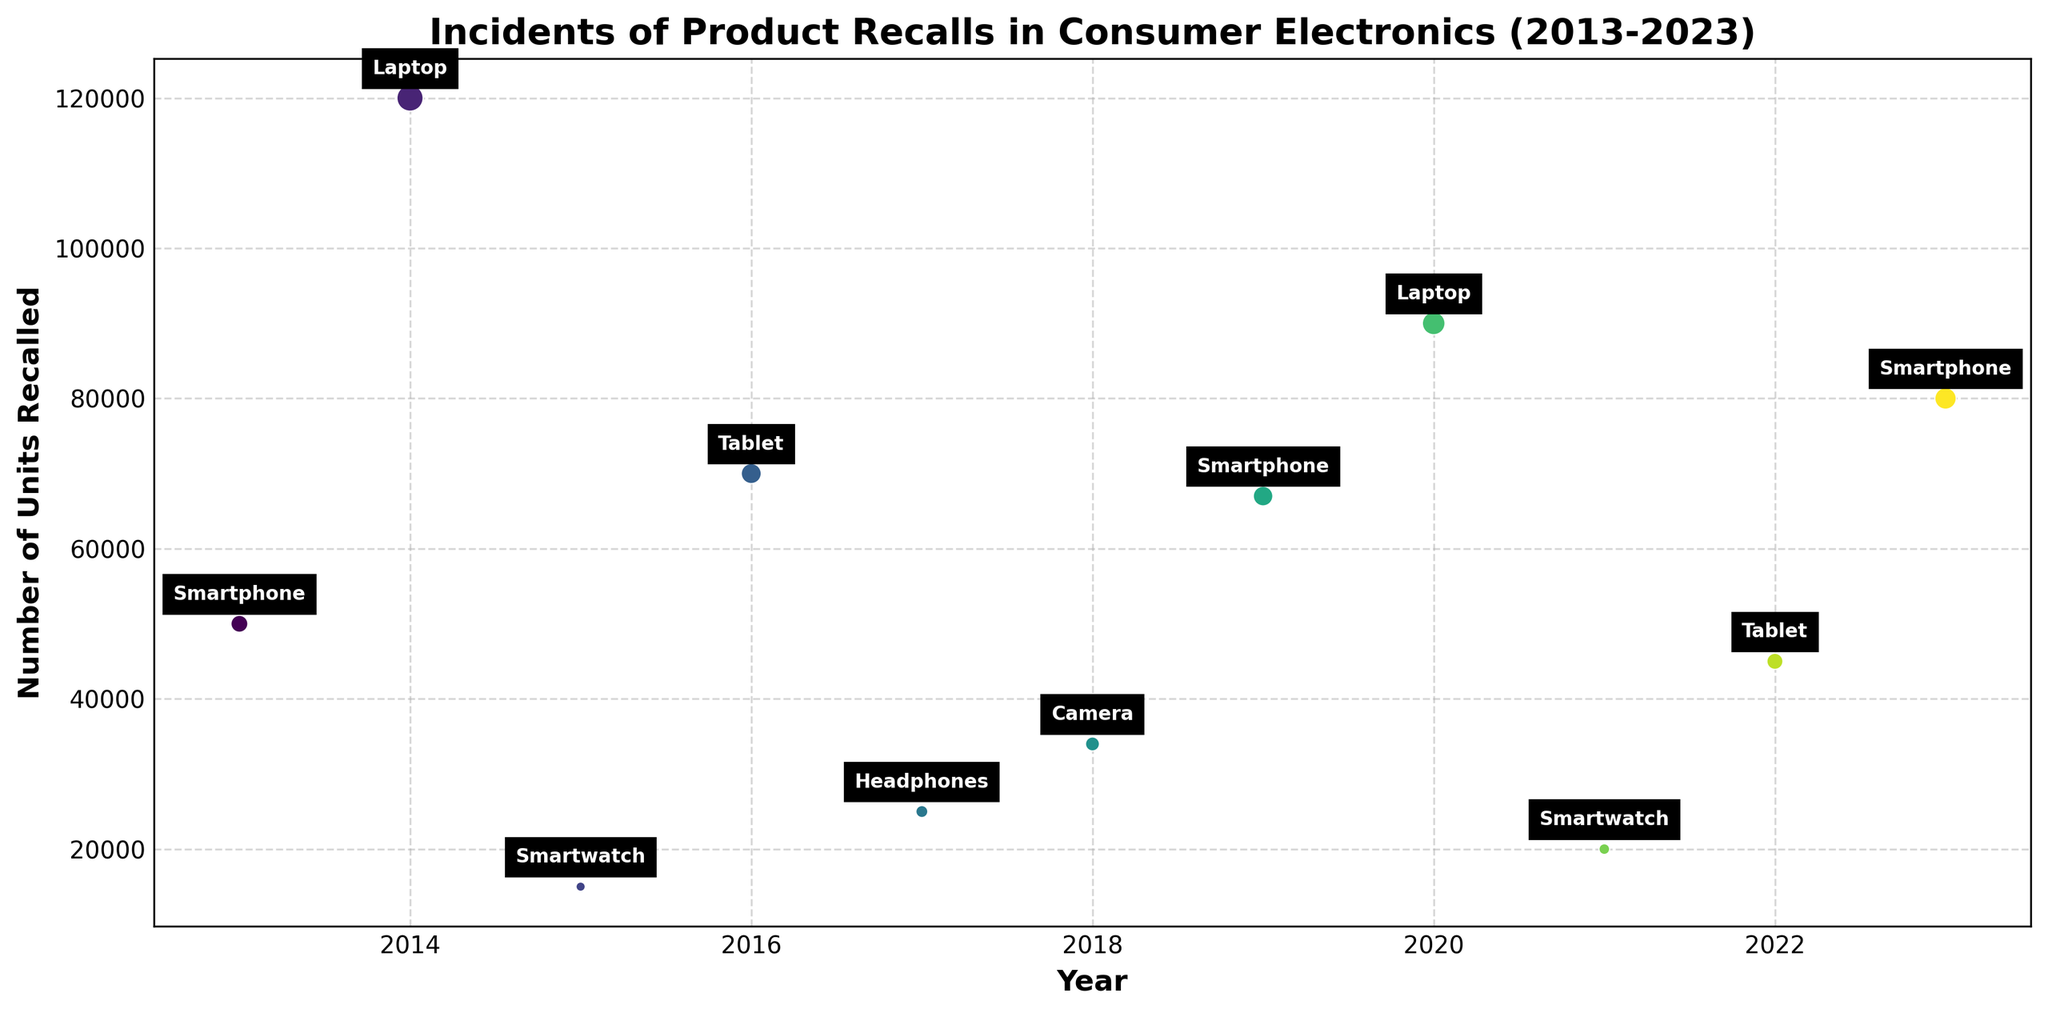What year had the highest number of product recalls? By inspecting the vertical positions on the y-axis, we can see which point is the highest. In the figure, the year 2014 has the highest point with 120,000 units recalled.
Answer: 2014 Which years had incidents of smartphone recalls, and how many units were recalled in each year? Look for the annotated labels "Smartphone" and note the corresponding years and y-axis positions. There are incidents in 2013 with 50,000 units, 2019 with 67,000 units, and 2023 with 80,000 units.
Answer: 2013 (50,000), 2019 (67,000), 2023 (80,000) What is the average number of units recalled in the years when Innovatech had incidents? Identify the points labeled "Tablet" associated with Innovatech in 2016 and 2022. Summing the units recalled (70,000 + 45,000) gives 115,000 units. Dividing this sum by the 2 incidents gives an average of 57,500 units.
Answer: 57,500 How did the number of units recalled for smartphones by ABC Electronics change from 2013 to 2019? Locate the incidents in 2013 and 2019 for ABC Electronics and compare the y-axis values. In 2013, 50,000 units were recalled, and in 2019, 67,000 units were recalled. The difference is 67,000 - 50,000 = 17,000 units.
Answer: Increased by 17,000 units Which product and year had the second-highest number of units recalled? Find the second highest point on the y-axis after the highest one in 2014. The second-highest point is in 2020 for laptops with 90,000 units recalled.
Answer: Laptop, 2020 How many incidents occurred in the USA, and what were the total units recalled? Identify all incidents in the USA and sum the units recalled. There are 3 incidents in 2013 (50,000), 2019 (67,000), and 2023 (80,000). The total number of units recalled is 50,000 + 67,000 + 80,000 = 197,000 units.
Answer: 3 incidents, 197,000 units Compare the units recalled for the same product (laptop) by XYZ Electronics in different years. Locate the incidents in 2014 and 2020 for laptops by XYZ Electronics. In 2014, 120,000 units were recalled, and in 2020, 90,000 units were recalled. The units recalled decreased by 30,000 units from 120,000 to 90,000.
Answer: Decreased by 30,000 units What are the total units recalled for products where the reason mentioned is related to hardware malfunction (Battery Overheating, Power Adapter Malfunction, Sensor Failure, Charging Port Defect)? Sum the units recalled for these reasons: 50,000 (2013) + 120,000 (2014) + 34,000 (2018) + 45,000 (2022) = 249,000 units.
Answer: 249,000 units What is the ratio of units recalled in 2023 to those recalled in 2021? Identify the units recalled for both years: 80,000 in 2023 and 20,000 in 2021. The ratio is 80,000 / 20,000 = 4:1.
Answer: 4:1 